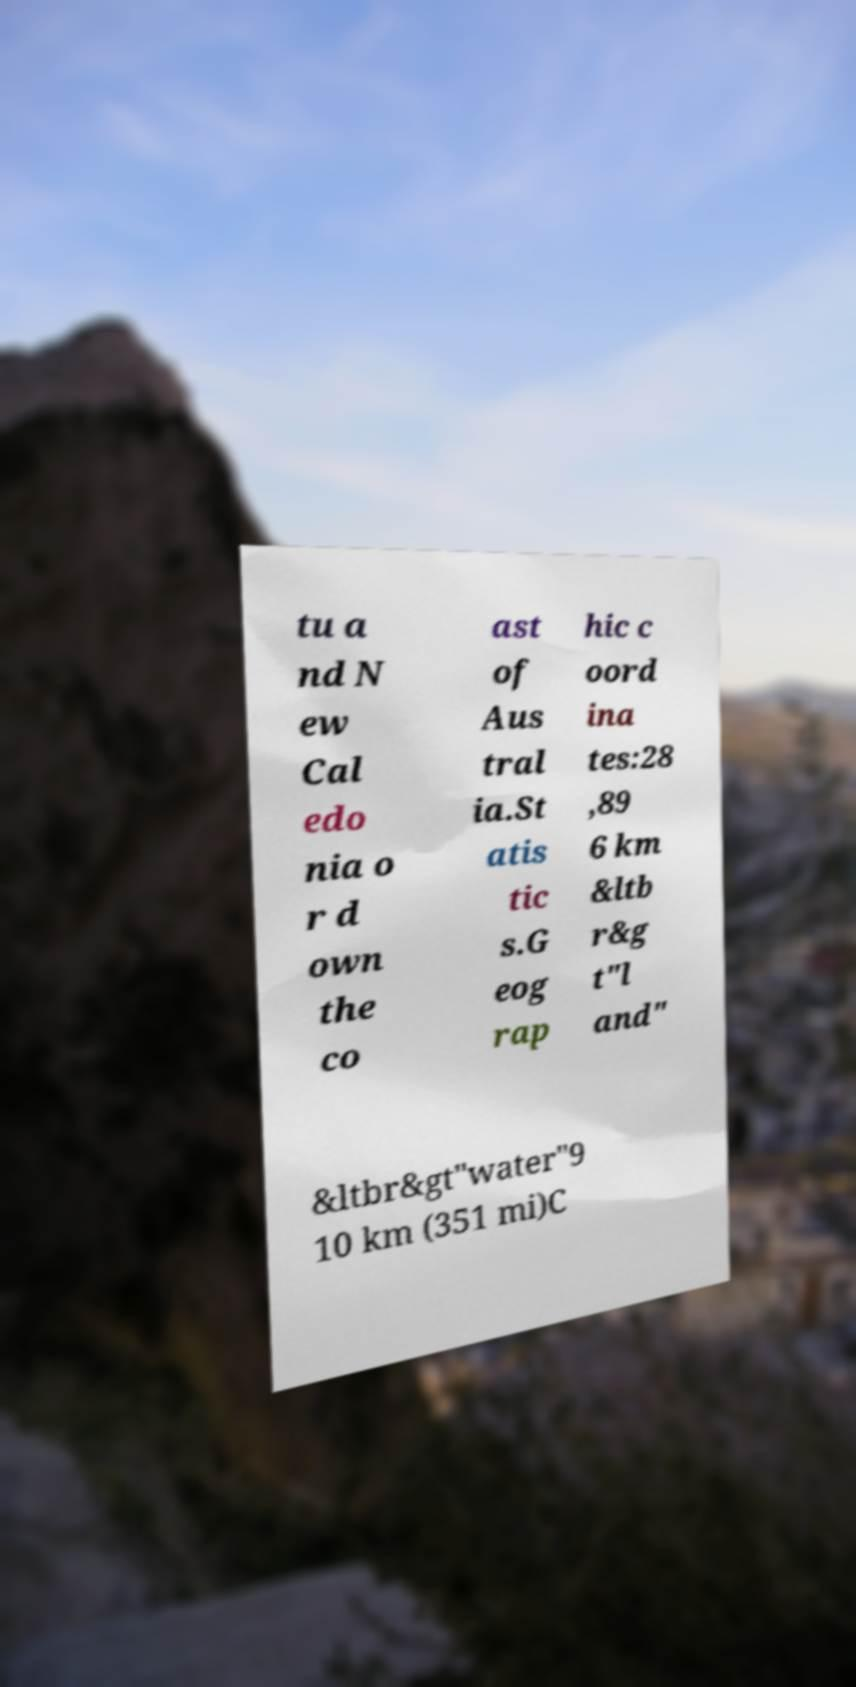What messages or text are displayed in this image? I need them in a readable, typed format. tu a nd N ew Cal edo nia o r d own the co ast of Aus tral ia.St atis tic s.G eog rap hic c oord ina tes:28 ,89 6 km &ltb r&g t"l and" &ltbr&gt"water"9 10 km (351 mi)C 